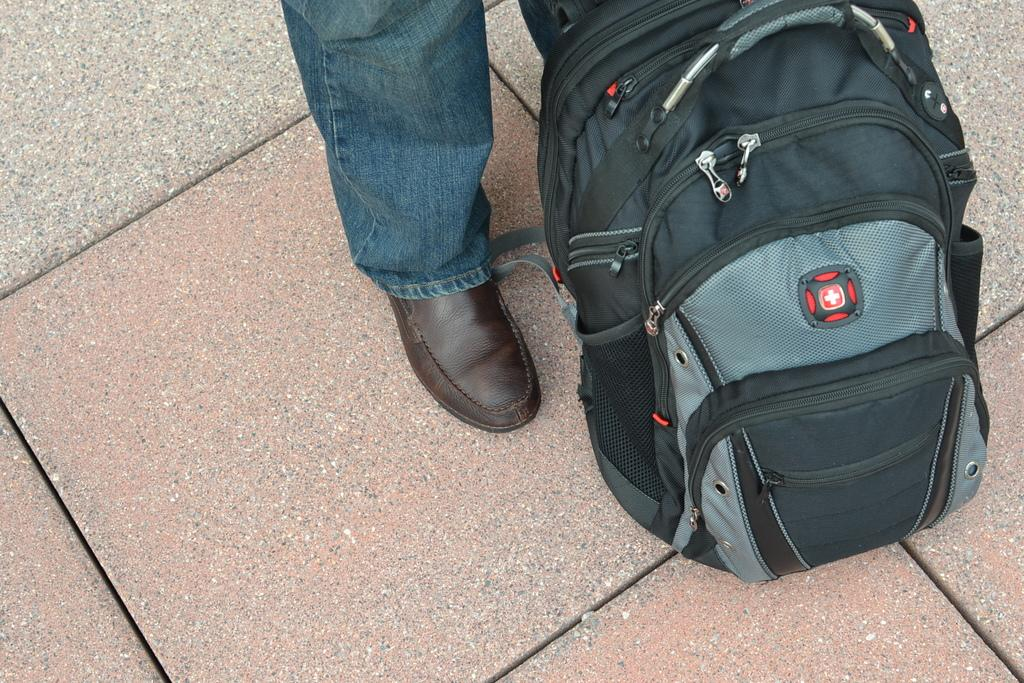What type of bag can be seen in the image? There is a black color bag in the image. Can you describe any part of the person in the image? A person's leg is visible in the image. What color are the jeans the person is wearing? The person is wearing blue color jeans. What color are the shoes the person is wearing? The person is wearing brown color shoes. How many sheep can be seen grazing in the image? There are no sheep present in the image. What type of growth is visible on the person's leg in the image? There is no growth visible on the person's leg in the image. 